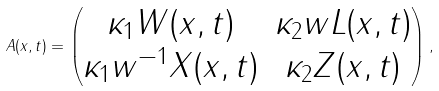Convert formula to latex. <formula><loc_0><loc_0><loc_500><loc_500>A ( x , t ) = \begin{pmatrix} \kappa _ { 1 } W ( x , t ) & \kappa _ { 2 } w L ( x , t ) \\ \kappa _ { 1 } w ^ { - 1 } X ( x , t ) & \kappa _ { 2 } Z ( x , t ) \end{pmatrix} ,</formula> 